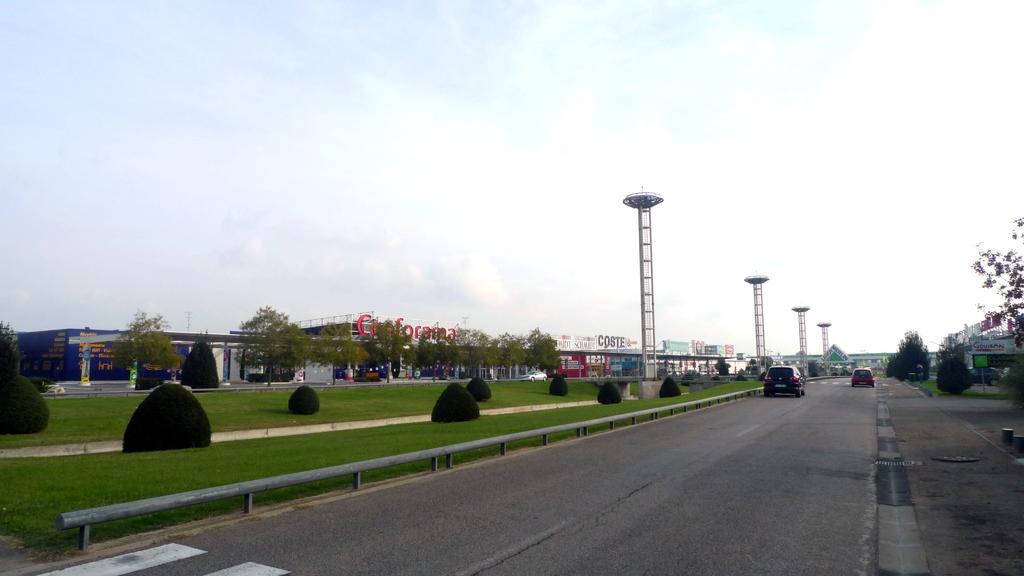Please provide a concise description of this image. In this image we can see motor vehicles on the road, ground, bushes, barriers, buildings, name boards, towers, trees and sky with clouds. 